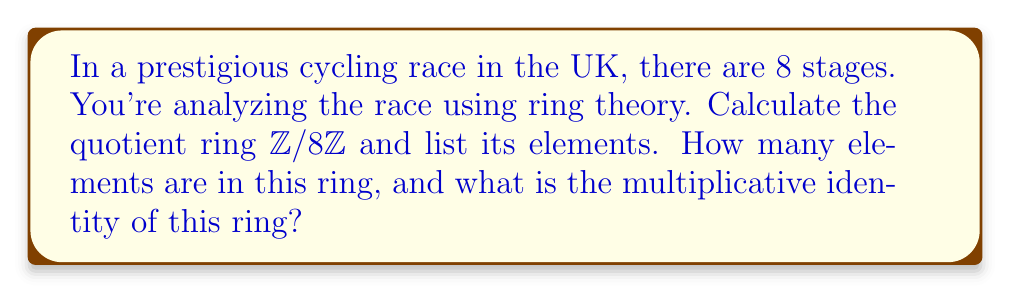Could you help me with this problem? Let's approach this step-by-step:

1) The quotient ring $\mathbb{Z}/8\mathbb{Z}$ is formed by considering the integers modulo 8.

2) The elements of this ring are the equivalence classes of integers under the equivalence relation of congruence modulo 8.

3) We can represent these equivalence classes as:

   $[0] = \{..., -8, 0, 8, 16, ...\}$
   $[1] = \{..., -7, 1, 9, 17, ...\}$
   $[2] = \{..., -6, 2, 10, 18, ...\}$
   $[3] = \{..., -5, 3, 11, 19, ...\}$
   $[4] = \{..., -4, 4, 12, 20, ...\}$
   $[5] = \{..., -3, 5, 13, 21, ...\}$
   $[6] = \{..., -2, 6, 14, 22, ...\}$
   $[7] = \{..., -1, 7, 15, 23, ...\}$

4) We typically represent these classes by their smallest non-negative representative. So, the elements of $\mathbb{Z}/8\mathbb{Z}$ are:

   $\{0, 1, 2, 3, 4, 5, 6, 7\}$

5) The number of elements in this ring is 8, which coincides with the number of stages in the race.

6) To find the multiplicative identity, we need to find an element $e$ such that $e \cdot a \equiv a \pmod{8}$ for all $a \in \mathbb{Z}/8\mathbb{Z}$.

7) The element 1 satisfies this condition:
   $1 \cdot 0 \equiv 0 \pmod{8}$
   $1 \cdot 1 \equiv 1 \pmod{8}$
   $1 \cdot 2 \equiv 2 \pmod{8}$
   ...
   $1 \cdot 7 \equiv 7 \pmod{8}$

Therefore, 1 is the multiplicative identity of this ring.
Answer: The quotient ring $\mathbb{Z}/8\mathbb{Z}$ has 8 elements: $\{0, 1, 2, 3, 4, 5, 6, 7\}$. The number of elements is 8, and the multiplicative identity of this ring is 1. 